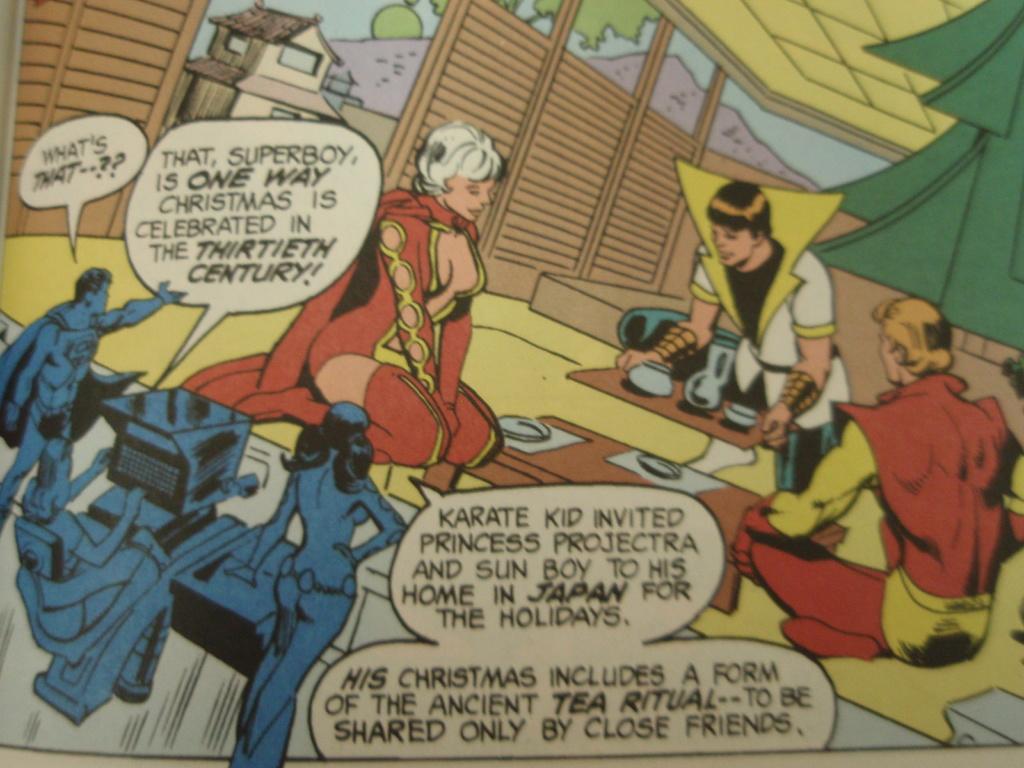Where is karate kid's home?
Your answer should be compact. Japan. 